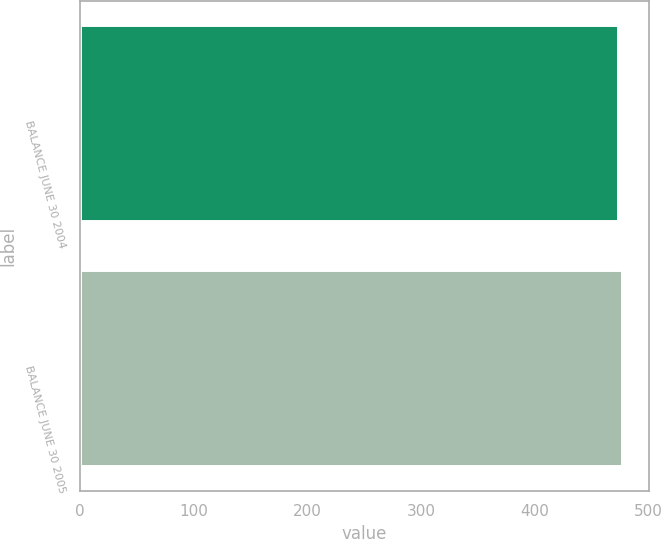Convert chart. <chart><loc_0><loc_0><loc_500><loc_500><bar_chart><fcel>BALANCE JUNE 30 2004<fcel>BALANCE JUNE 30 2005<nl><fcel>473.1<fcel>476.5<nl></chart> 